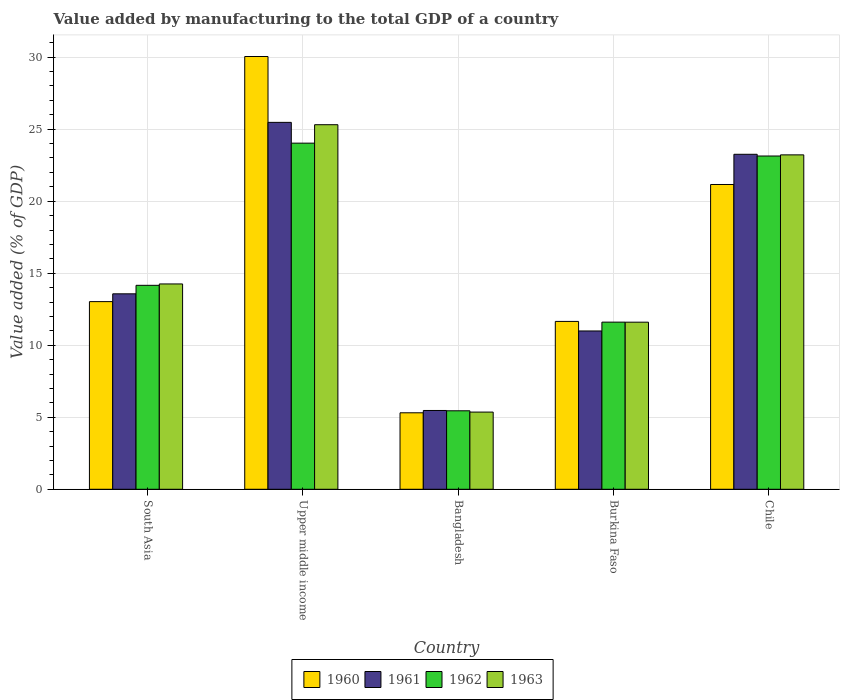How many groups of bars are there?
Offer a terse response. 5. Are the number of bars per tick equal to the number of legend labels?
Offer a very short reply. Yes. How many bars are there on the 3rd tick from the left?
Ensure brevity in your answer.  4. How many bars are there on the 5th tick from the right?
Provide a short and direct response. 4. In how many cases, is the number of bars for a given country not equal to the number of legend labels?
Keep it short and to the point. 0. What is the value added by manufacturing to the total GDP in 1961 in Upper middle income?
Offer a very short reply. 25.47. Across all countries, what is the maximum value added by manufacturing to the total GDP in 1961?
Offer a very short reply. 25.47. Across all countries, what is the minimum value added by manufacturing to the total GDP in 1963?
Your response must be concise. 5.36. In which country was the value added by manufacturing to the total GDP in 1961 maximum?
Your answer should be compact. Upper middle income. What is the total value added by manufacturing to the total GDP in 1961 in the graph?
Your response must be concise. 78.76. What is the difference between the value added by manufacturing to the total GDP in 1962 in Chile and that in South Asia?
Your answer should be very brief. 8.98. What is the difference between the value added by manufacturing to the total GDP in 1960 in South Asia and the value added by manufacturing to the total GDP in 1961 in Bangladesh?
Ensure brevity in your answer.  7.56. What is the average value added by manufacturing to the total GDP in 1960 per country?
Make the answer very short. 16.24. What is the difference between the value added by manufacturing to the total GDP of/in 1963 and value added by manufacturing to the total GDP of/in 1961 in Chile?
Your answer should be compact. -0.04. What is the ratio of the value added by manufacturing to the total GDP in 1960 in Burkina Faso to that in South Asia?
Offer a terse response. 0.89. Is the value added by manufacturing to the total GDP in 1961 in Burkina Faso less than that in South Asia?
Make the answer very short. Yes. What is the difference between the highest and the second highest value added by manufacturing to the total GDP in 1961?
Keep it short and to the point. 11.9. What is the difference between the highest and the lowest value added by manufacturing to the total GDP in 1960?
Ensure brevity in your answer.  24.74. In how many countries, is the value added by manufacturing to the total GDP in 1963 greater than the average value added by manufacturing to the total GDP in 1963 taken over all countries?
Your response must be concise. 2. Is the sum of the value added by manufacturing to the total GDP in 1963 in Chile and Upper middle income greater than the maximum value added by manufacturing to the total GDP in 1962 across all countries?
Your answer should be compact. Yes. What does the 3rd bar from the right in Bangladesh represents?
Ensure brevity in your answer.  1961. Are all the bars in the graph horizontal?
Keep it short and to the point. No. How many countries are there in the graph?
Keep it short and to the point. 5. What is the title of the graph?
Your answer should be very brief. Value added by manufacturing to the total GDP of a country. What is the label or title of the X-axis?
Your answer should be very brief. Country. What is the label or title of the Y-axis?
Your answer should be very brief. Value added (% of GDP). What is the Value added (% of GDP) in 1960 in South Asia?
Give a very brief answer. 13.03. What is the Value added (% of GDP) of 1961 in South Asia?
Your answer should be compact. 13.57. What is the Value added (% of GDP) in 1962 in South Asia?
Make the answer very short. 14.16. What is the Value added (% of GDP) of 1963 in South Asia?
Provide a short and direct response. 14.26. What is the Value added (% of GDP) in 1960 in Upper middle income?
Ensure brevity in your answer.  30.05. What is the Value added (% of GDP) in 1961 in Upper middle income?
Offer a very short reply. 25.47. What is the Value added (% of GDP) in 1962 in Upper middle income?
Provide a short and direct response. 24.03. What is the Value added (% of GDP) in 1963 in Upper middle income?
Provide a short and direct response. 25.31. What is the Value added (% of GDP) of 1960 in Bangladesh?
Make the answer very short. 5.31. What is the Value added (% of GDP) in 1961 in Bangladesh?
Ensure brevity in your answer.  5.47. What is the Value added (% of GDP) of 1962 in Bangladesh?
Provide a short and direct response. 5.45. What is the Value added (% of GDP) in 1963 in Bangladesh?
Provide a succinct answer. 5.36. What is the Value added (% of GDP) in 1960 in Burkina Faso?
Provide a succinct answer. 11.65. What is the Value added (% of GDP) of 1961 in Burkina Faso?
Give a very brief answer. 10.99. What is the Value added (% of GDP) of 1962 in Burkina Faso?
Keep it short and to the point. 11.6. What is the Value added (% of GDP) of 1963 in Burkina Faso?
Make the answer very short. 11.6. What is the Value added (% of GDP) in 1960 in Chile?
Ensure brevity in your answer.  21.16. What is the Value added (% of GDP) in 1961 in Chile?
Keep it short and to the point. 23.26. What is the Value added (% of GDP) of 1962 in Chile?
Your answer should be compact. 23.14. What is the Value added (% of GDP) of 1963 in Chile?
Offer a very short reply. 23.22. Across all countries, what is the maximum Value added (% of GDP) in 1960?
Your answer should be very brief. 30.05. Across all countries, what is the maximum Value added (% of GDP) of 1961?
Ensure brevity in your answer.  25.47. Across all countries, what is the maximum Value added (% of GDP) in 1962?
Your answer should be very brief. 24.03. Across all countries, what is the maximum Value added (% of GDP) of 1963?
Give a very brief answer. 25.31. Across all countries, what is the minimum Value added (% of GDP) of 1960?
Keep it short and to the point. 5.31. Across all countries, what is the minimum Value added (% of GDP) in 1961?
Make the answer very short. 5.47. Across all countries, what is the minimum Value added (% of GDP) in 1962?
Your answer should be compact. 5.45. Across all countries, what is the minimum Value added (% of GDP) of 1963?
Offer a terse response. 5.36. What is the total Value added (% of GDP) in 1960 in the graph?
Ensure brevity in your answer.  81.2. What is the total Value added (% of GDP) in 1961 in the graph?
Make the answer very short. 78.76. What is the total Value added (% of GDP) in 1962 in the graph?
Keep it short and to the point. 78.38. What is the total Value added (% of GDP) of 1963 in the graph?
Provide a short and direct response. 79.74. What is the difference between the Value added (% of GDP) in 1960 in South Asia and that in Upper middle income?
Your response must be concise. -17.02. What is the difference between the Value added (% of GDP) in 1961 in South Asia and that in Upper middle income?
Provide a short and direct response. -11.9. What is the difference between the Value added (% of GDP) in 1962 in South Asia and that in Upper middle income?
Your answer should be compact. -9.87. What is the difference between the Value added (% of GDP) of 1963 in South Asia and that in Upper middle income?
Your response must be concise. -11.05. What is the difference between the Value added (% of GDP) of 1960 in South Asia and that in Bangladesh?
Keep it short and to the point. 7.72. What is the difference between the Value added (% of GDP) in 1961 in South Asia and that in Bangladesh?
Provide a short and direct response. 8.1. What is the difference between the Value added (% of GDP) in 1962 in South Asia and that in Bangladesh?
Offer a very short reply. 8.71. What is the difference between the Value added (% of GDP) in 1963 in South Asia and that in Bangladesh?
Provide a succinct answer. 8.9. What is the difference between the Value added (% of GDP) in 1960 in South Asia and that in Burkina Faso?
Keep it short and to the point. 1.37. What is the difference between the Value added (% of GDP) of 1961 in South Asia and that in Burkina Faso?
Offer a very short reply. 2.58. What is the difference between the Value added (% of GDP) of 1962 in South Asia and that in Burkina Faso?
Your response must be concise. 2.56. What is the difference between the Value added (% of GDP) of 1963 in South Asia and that in Burkina Faso?
Give a very brief answer. 2.66. What is the difference between the Value added (% of GDP) of 1960 in South Asia and that in Chile?
Provide a short and direct response. -8.13. What is the difference between the Value added (% of GDP) in 1961 in South Asia and that in Chile?
Offer a terse response. -9.69. What is the difference between the Value added (% of GDP) of 1962 in South Asia and that in Chile?
Give a very brief answer. -8.98. What is the difference between the Value added (% of GDP) in 1963 in South Asia and that in Chile?
Give a very brief answer. -8.96. What is the difference between the Value added (% of GDP) of 1960 in Upper middle income and that in Bangladesh?
Ensure brevity in your answer.  24.74. What is the difference between the Value added (% of GDP) in 1961 in Upper middle income and that in Bangladesh?
Provide a short and direct response. 20. What is the difference between the Value added (% of GDP) in 1962 in Upper middle income and that in Bangladesh?
Provide a succinct answer. 18.58. What is the difference between the Value added (% of GDP) in 1963 in Upper middle income and that in Bangladesh?
Make the answer very short. 19.95. What is the difference between the Value added (% of GDP) in 1960 in Upper middle income and that in Burkina Faso?
Provide a short and direct response. 18.39. What is the difference between the Value added (% of GDP) of 1961 in Upper middle income and that in Burkina Faso?
Keep it short and to the point. 14.48. What is the difference between the Value added (% of GDP) of 1962 in Upper middle income and that in Burkina Faso?
Provide a short and direct response. 12.43. What is the difference between the Value added (% of GDP) in 1963 in Upper middle income and that in Burkina Faso?
Offer a terse response. 13.71. What is the difference between the Value added (% of GDP) of 1960 in Upper middle income and that in Chile?
Your answer should be very brief. 8.89. What is the difference between the Value added (% of GDP) of 1961 in Upper middle income and that in Chile?
Offer a terse response. 2.22. What is the difference between the Value added (% of GDP) in 1962 in Upper middle income and that in Chile?
Make the answer very short. 0.89. What is the difference between the Value added (% of GDP) of 1963 in Upper middle income and that in Chile?
Your answer should be compact. 2.09. What is the difference between the Value added (% of GDP) of 1960 in Bangladesh and that in Burkina Faso?
Your response must be concise. -6.34. What is the difference between the Value added (% of GDP) in 1961 in Bangladesh and that in Burkina Faso?
Your answer should be very brief. -5.52. What is the difference between the Value added (% of GDP) in 1962 in Bangladesh and that in Burkina Faso?
Your answer should be compact. -6.16. What is the difference between the Value added (% of GDP) of 1963 in Bangladesh and that in Burkina Faso?
Your response must be concise. -6.24. What is the difference between the Value added (% of GDP) in 1960 in Bangladesh and that in Chile?
Make the answer very short. -15.85. What is the difference between the Value added (% of GDP) in 1961 in Bangladesh and that in Chile?
Your answer should be very brief. -17.79. What is the difference between the Value added (% of GDP) in 1962 in Bangladesh and that in Chile?
Offer a very short reply. -17.69. What is the difference between the Value added (% of GDP) of 1963 in Bangladesh and that in Chile?
Give a very brief answer. -17.86. What is the difference between the Value added (% of GDP) in 1960 in Burkina Faso and that in Chile?
Your answer should be very brief. -9.51. What is the difference between the Value added (% of GDP) in 1961 in Burkina Faso and that in Chile?
Make the answer very short. -12.27. What is the difference between the Value added (% of GDP) of 1962 in Burkina Faso and that in Chile?
Make the answer very short. -11.53. What is the difference between the Value added (% of GDP) of 1963 in Burkina Faso and that in Chile?
Provide a succinct answer. -11.62. What is the difference between the Value added (% of GDP) of 1960 in South Asia and the Value added (% of GDP) of 1961 in Upper middle income?
Ensure brevity in your answer.  -12.44. What is the difference between the Value added (% of GDP) of 1960 in South Asia and the Value added (% of GDP) of 1962 in Upper middle income?
Provide a succinct answer. -11. What is the difference between the Value added (% of GDP) in 1960 in South Asia and the Value added (% of GDP) in 1963 in Upper middle income?
Make the answer very short. -12.28. What is the difference between the Value added (% of GDP) of 1961 in South Asia and the Value added (% of GDP) of 1962 in Upper middle income?
Keep it short and to the point. -10.46. What is the difference between the Value added (% of GDP) of 1961 in South Asia and the Value added (% of GDP) of 1963 in Upper middle income?
Provide a short and direct response. -11.74. What is the difference between the Value added (% of GDP) in 1962 in South Asia and the Value added (% of GDP) in 1963 in Upper middle income?
Ensure brevity in your answer.  -11.15. What is the difference between the Value added (% of GDP) in 1960 in South Asia and the Value added (% of GDP) in 1961 in Bangladesh?
Keep it short and to the point. 7.56. What is the difference between the Value added (% of GDP) of 1960 in South Asia and the Value added (% of GDP) of 1962 in Bangladesh?
Your answer should be compact. 7.58. What is the difference between the Value added (% of GDP) in 1960 in South Asia and the Value added (% of GDP) in 1963 in Bangladesh?
Ensure brevity in your answer.  7.67. What is the difference between the Value added (% of GDP) in 1961 in South Asia and the Value added (% of GDP) in 1962 in Bangladesh?
Your answer should be very brief. 8.12. What is the difference between the Value added (% of GDP) in 1961 in South Asia and the Value added (% of GDP) in 1963 in Bangladesh?
Your response must be concise. 8.21. What is the difference between the Value added (% of GDP) of 1962 in South Asia and the Value added (% of GDP) of 1963 in Bangladesh?
Provide a short and direct response. 8.8. What is the difference between the Value added (% of GDP) of 1960 in South Asia and the Value added (% of GDP) of 1961 in Burkina Faso?
Give a very brief answer. 2.04. What is the difference between the Value added (% of GDP) in 1960 in South Asia and the Value added (% of GDP) in 1962 in Burkina Faso?
Provide a succinct answer. 1.43. What is the difference between the Value added (% of GDP) of 1960 in South Asia and the Value added (% of GDP) of 1963 in Burkina Faso?
Provide a short and direct response. 1.43. What is the difference between the Value added (% of GDP) of 1961 in South Asia and the Value added (% of GDP) of 1962 in Burkina Faso?
Your response must be concise. 1.97. What is the difference between the Value added (% of GDP) in 1961 in South Asia and the Value added (% of GDP) in 1963 in Burkina Faso?
Ensure brevity in your answer.  1.97. What is the difference between the Value added (% of GDP) of 1962 in South Asia and the Value added (% of GDP) of 1963 in Burkina Faso?
Keep it short and to the point. 2.56. What is the difference between the Value added (% of GDP) of 1960 in South Asia and the Value added (% of GDP) of 1961 in Chile?
Provide a short and direct response. -10.23. What is the difference between the Value added (% of GDP) of 1960 in South Asia and the Value added (% of GDP) of 1962 in Chile?
Offer a terse response. -10.11. What is the difference between the Value added (% of GDP) in 1960 in South Asia and the Value added (% of GDP) in 1963 in Chile?
Keep it short and to the point. -10.19. What is the difference between the Value added (% of GDP) in 1961 in South Asia and the Value added (% of GDP) in 1962 in Chile?
Make the answer very short. -9.57. What is the difference between the Value added (% of GDP) of 1961 in South Asia and the Value added (% of GDP) of 1963 in Chile?
Offer a very short reply. -9.65. What is the difference between the Value added (% of GDP) in 1962 in South Asia and the Value added (% of GDP) in 1963 in Chile?
Make the answer very short. -9.06. What is the difference between the Value added (% of GDP) of 1960 in Upper middle income and the Value added (% of GDP) of 1961 in Bangladesh?
Provide a succinct answer. 24.57. What is the difference between the Value added (% of GDP) in 1960 in Upper middle income and the Value added (% of GDP) in 1962 in Bangladesh?
Give a very brief answer. 24.6. What is the difference between the Value added (% of GDP) in 1960 in Upper middle income and the Value added (% of GDP) in 1963 in Bangladesh?
Provide a succinct answer. 24.69. What is the difference between the Value added (% of GDP) of 1961 in Upper middle income and the Value added (% of GDP) of 1962 in Bangladesh?
Provide a short and direct response. 20.03. What is the difference between the Value added (% of GDP) of 1961 in Upper middle income and the Value added (% of GDP) of 1963 in Bangladesh?
Keep it short and to the point. 20.11. What is the difference between the Value added (% of GDP) of 1962 in Upper middle income and the Value added (% of GDP) of 1963 in Bangladesh?
Offer a terse response. 18.67. What is the difference between the Value added (% of GDP) of 1960 in Upper middle income and the Value added (% of GDP) of 1961 in Burkina Faso?
Provide a short and direct response. 19.05. What is the difference between the Value added (% of GDP) of 1960 in Upper middle income and the Value added (% of GDP) of 1962 in Burkina Faso?
Ensure brevity in your answer.  18.44. What is the difference between the Value added (% of GDP) of 1960 in Upper middle income and the Value added (% of GDP) of 1963 in Burkina Faso?
Make the answer very short. 18.44. What is the difference between the Value added (% of GDP) of 1961 in Upper middle income and the Value added (% of GDP) of 1962 in Burkina Faso?
Ensure brevity in your answer.  13.87. What is the difference between the Value added (% of GDP) of 1961 in Upper middle income and the Value added (% of GDP) of 1963 in Burkina Faso?
Offer a very short reply. 13.87. What is the difference between the Value added (% of GDP) in 1962 in Upper middle income and the Value added (% of GDP) in 1963 in Burkina Faso?
Provide a short and direct response. 12.43. What is the difference between the Value added (% of GDP) in 1960 in Upper middle income and the Value added (% of GDP) in 1961 in Chile?
Provide a short and direct response. 6.79. What is the difference between the Value added (% of GDP) in 1960 in Upper middle income and the Value added (% of GDP) in 1962 in Chile?
Your answer should be very brief. 6.91. What is the difference between the Value added (% of GDP) in 1960 in Upper middle income and the Value added (% of GDP) in 1963 in Chile?
Your response must be concise. 6.83. What is the difference between the Value added (% of GDP) of 1961 in Upper middle income and the Value added (% of GDP) of 1962 in Chile?
Your answer should be compact. 2.34. What is the difference between the Value added (% of GDP) of 1961 in Upper middle income and the Value added (% of GDP) of 1963 in Chile?
Offer a very short reply. 2.26. What is the difference between the Value added (% of GDP) in 1962 in Upper middle income and the Value added (% of GDP) in 1963 in Chile?
Provide a succinct answer. 0.81. What is the difference between the Value added (% of GDP) in 1960 in Bangladesh and the Value added (% of GDP) in 1961 in Burkina Faso?
Give a very brief answer. -5.68. What is the difference between the Value added (% of GDP) of 1960 in Bangladesh and the Value added (% of GDP) of 1962 in Burkina Faso?
Keep it short and to the point. -6.29. What is the difference between the Value added (% of GDP) of 1960 in Bangladesh and the Value added (% of GDP) of 1963 in Burkina Faso?
Offer a very short reply. -6.29. What is the difference between the Value added (% of GDP) of 1961 in Bangladesh and the Value added (% of GDP) of 1962 in Burkina Faso?
Provide a succinct answer. -6.13. What is the difference between the Value added (% of GDP) in 1961 in Bangladesh and the Value added (% of GDP) in 1963 in Burkina Faso?
Your answer should be very brief. -6.13. What is the difference between the Value added (% of GDP) of 1962 in Bangladesh and the Value added (% of GDP) of 1963 in Burkina Faso?
Your answer should be very brief. -6.15. What is the difference between the Value added (% of GDP) of 1960 in Bangladesh and the Value added (% of GDP) of 1961 in Chile?
Your response must be concise. -17.95. What is the difference between the Value added (% of GDP) in 1960 in Bangladesh and the Value added (% of GDP) in 1962 in Chile?
Keep it short and to the point. -17.83. What is the difference between the Value added (% of GDP) in 1960 in Bangladesh and the Value added (% of GDP) in 1963 in Chile?
Offer a terse response. -17.91. What is the difference between the Value added (% of GDP) in 1961 in Bangladesh and the Value added (% of GDP) in 1962 in Chile?
Offer a very short reply. -17.67. What is the difference between the Value added (% of GDP) in 1961 in Bangladesh and the Value added (% of GDP) in 1963 in Chile?
Give a very brief answer. -17.75. What is the difference between the Value added (% of GDP) in 1962 in Bangladesh and the Value added (% of GDP) in 1963 in Chile?
Your answer should be compact. -17.77. What is the difference between the Value added (% of GDP) in 1960 in Burkina Faso and the Value added (% of GDP) in 1961 in Chile?
Give a very brief answer. -11.6. What is the difference between the Value added (% of GDP) in 1960 in Burkina Faso and the Value added (% of GDP) in 1962 in Chile?
Your response must be concise. -11.48. What is the difference between the Value added (% of GDP) in 1960 in Burkina Faso and the Value added (% of GDP) in 1963 in Chile?
Your answer should be compact. -11.56. What is the difference between the Value added (% of GDP) in 1961 in Burkina Faso and the Value added (% of GDP) in 1962 in Chile?
Provide a short and direct response. -12.15. What is the difference between the Value added (% of GDP) of 1961 in Burkina Faso and the Value added (% of GDP) of 1963 in Chile?
Offer a terse response. -12.23. What is the difference between the Value added (% of GDP) in 1962 in Burkina Faso and the Value added (% of GDP) in 1963 in Chile?
Your response must be concise. -11.61. What is the average Value added (% of GDP) of 1960 per country?
Provide a succinct answer. 16.24. What is the average Value added (% of GDP) in 1961 per country?
Offer a terse response. 15.75. What is the average Value added (% of GDP) of 1962 per country?
Your response must be concise. 15.68. What is the average Value added (% of GDP) of 1963 per country?
Your answer should be compact. 15.95. What is the difference between the Value added (% of GDP) of 1960 and Value added (% of GDP) of 1961 in South Asia?
Provide a succinct answer. -0.54. What is the difference between the Value added (% of GDP) of 1960 and Value added (% of GDP) of 1962 in South Asia?
Ensure brevity in your answer.  -1.13. What is the difference between the Value added (% of GDP) in 1960 and Value added (% of GDP) in 1963 in South Asia?
Ensure brevity in your answer.  -1.23. What is the difference between the Value added (% of GDP) in 1961 and Value added (% of GDP) in 1962 in South Asia?
Offer a very short reply. -0.59. What is the difference between the Value added (% of GDP) in 1961 and Value added (% of GDP) in 1963 in South Asia?
Offer a very short reply. -0.69. What is the difference between the Value added (% of GDP) in 1962 and Value added (% of GDP) in 1963 in South Asia?
Offer a terse response. -0.1. What is the difference between the Value added (% of GDP) of 1960 and Value added (% of GDP) of 1961 in Upper middle income?
Give a very brief answer. 4.57. What is the difference between the Value added (% of GDP) in 1960 and Value added (% of GDP) in 1962 in Upper middle income?
Your response must be concise. 6.01. What is the difference between the Value added (% of GDP) in 1960 and Value added (% of GDP) in 1963 in Upper middle income?
Offer a terse response. 4.73. What is the difference between the Value added (% of GDP) in 1961 and Value added (% of GDP) in 1962 in Upper middle income?
Offer a terse response. 1.44. What is the difference between the Value added (% of GDP) of 1961 and Value added (% of GDP) of 1963 in Upper middle income?
Your answer should be very brief. 0.16. What is the difference between the Value added (% of GDP) in 1962 and Value added (% of GDP) in 1963 in Upper middle income?
Give a very brief answer. -1.28. What is the difference between the Value added (% of GDP) in 1960 and Value added (% of GDP) in 1961 in Bangladesh?
Offer a very short reply. -0.16. What is the difference between the Value added (% of GDP) in 1960 and Value added (% of GDP) in 1962 in Bangladesh?
Your answer should be compact. -0.14. What is the difference between the Value added (% of GDP) of 1960 and Value added (% of GDP) of 1963 in Bangladesh?
Offer a very short reply. -0.05. What is the difference between the Value added (% of GDP) in 1961 and Value added (% of GDP) in 1962 in Bangladesh?
Your answer should be very brief. 0.02. What is the difference between the Value added (% of GDP) in 1961 and Value added (% of GDP) in 1963 in Bangladesh?
Ensure brevity in your answer.  0.11. What is the difference between the Value added (% of GDP) of 1962 and Value added (% of GDP) of 1963 in Bangladesh?
Give a very brief answer. 0.09. What is the difference between the Value added (% of GDP) in 1960 and Value added (% of GDP) in 1961 in Burkina Faso?
Give a very brief answer. 0.66. What is the difference between the Value added (% of GDP) in 1960 and Value added (% of GDP) in 1962 in Burkina Faso?
Your answer should be compact. 0.05. What is the difference between the Value added (% of GDP) of 1960 and Value added (% of GDP) of 1963 in Burkina Faso?
Your answer should be compact. 0.05. What is the difference between the Value added (% of GDP) in 1961 and Value added (% of GDP) in 1962 in Burkina Faso?
Your response must be concise. -0.61. What is the difference between the Value added (% of GDP) of 1961 and Value added (% of GDP) of 1963 in Burkina Faso?
Make the answer very short. -0.61. What is the difference between the Value added (% of GDP) of 1962 and Value added (% of GDP) of 1963 in Burkina Faso?
Make the answer very short. 0. What is the difference between the Value added (% of GDP) in 1960 and Value added (% of GDP) in 1961 in Chile?
Offer a very short reply. -2.1. What is the difference between the Value added (% of GDP) of 1960 and Value added (% of GDP) of 1962 in Chile?
Your answer should be compact. -1.98. What is the difference between the Value added (% of GDP) in 1960 and Value added (% of GDP) in 1963 in Chile?
Your answer should be very brief. -2.06. What is the difference between the Value added (% of GDP) in 1961 and Value added (% of GDP) in 1962 in Chile?
Your response must be concise. 0.12. What is the difference between the Value added (% of GDP) in 1961 and Value added (% of GDP) in 1963 in Chile?
Your response must be concise. 0.04. What is the difference between the Value added (% of GDP) in 1962 and Value added (% of GDP) in 1963 in Chile?
Offer a very short reply. -0.08. What is the ratio of the Value added (% of GDP) of 1960 in South Asia to that in Upper middle income?
Your answer should be very brief. 0.43. What is the ratio of the Value added (% of GDP) of 1961 in South Asia to that in Upper middle income?
Keep it short and to the point. 0.53. What is the ratio of the Value added (% of GDP) of 1962 in South Asia to that in Upper middle income?
Provide a short and direct response. 0.59. What is the ratio of the Value added (% of GDP) of 1963 in South Asia to that in Upper middle income?
Make the answer very short. 0.56. What is the ratio of the Value added (% of GDP) in 1960 in South Asia to that in Bangladesh?
Your answer should be very brief. 2.45. What is the ratio of the Value added (% of GDP) of 1961 in South Asia to that in Bangladesh?
Your response must be concise. 2.48. What is the ratio of the Value added (% of GDP) in 1962 in South Asia to that in Bangladesh?
Your response must be concise. 2.6. What is the ratio of the Value added (% of GDP) of 1963 in South Asia to that in Bangladesh?
Your answer should be very brief. 2.66. What is the ratio of the Value added (% of GDP) of 1960 in South Asia to that in Burkina Faso?
Offer a very short reply. 1.12. What is the ratio of the Value added (% of GDP) of 1961 in South Asia to that in Burkina Faso?
Offer a very short reply. 1.23. What is the ratio of the Value added (% of GDP) of 1962 in South Asia to that in Burkina Faso?
Make the answer very short. 1.22. What is the ratio of the Value added (% of GDP) of 1963 in South Asia to that in Burkina Faso?
Provide a succinct answer. 1.23. What is the ratio of the Value added (% of GDP) of 1960 in South Asia to that in Chile?
Your answer should be very brief. 0.62. What is the ratio of the Value added (% of GDP) in 1961 in South Asia to that in Chile?
Keep it short and to the point. 0.58. What is the ratio of the Value added (% of GDP) of 1962 in South Asia to that in Chile?
Make the answer very short. 0.61. What is the ratio of the Value added (% of GDP) in 1963 in South Asia to that in Chile?
Your answer should be very brief. 0.61. What is the ratio of the Value added (% of GDP) of 1960 in Upper middle income to that in Bangladesh?
Offer a very short reply. 5.66. What is the ratio of the Value added (% of GDP) of 1961 in Upper middle income to that in Bangladesh?
Offer a terse response. 4.66. What is the ratio of the Value added (% of GDP) in 1962 in Upper middle income to that in Bangladesh?
Offer a very short reply. 4.41. What is the ratio of the Value added (% of GDP) of 1963 in Upper middle income to that in Bangladesh?
Provide a succinct answer. 4.72. What is the ratio of the Value added (% of GDP) in 1960 in Upper middle income to that in Burkina Faso?
Offer a terse response. 2.58. What is the ratio of the Value added (% of GDP) in 1961 in Upper middle income to that in Burkina Faso?
Give a very brief answer. 2.32. What is the ratio of the Value added (% of GDP) of 1962 in Upper middle income to that in Burkina Faso?
Provide a short and direct response. 2.07. What is the ratio of the Value added (% of GDP) of 1963 in Upper middle income to that in Burkina Faso?
Keep it short and to the point. 2.18. What is the ratio of the Value added (% of GDP) of 1960 in Upper middle income to that in Chile?
Make the answer very short. 1.42. What is the ratio of the Value added (% of GDP) of 1961 in Upper middle income to that in Chile?
Keep it short and to the point. 1.1. What is the ratio of the Value added (% of GDP) in 1962 in Upper middle income to that in Chile?
Your answer should be very brief. 1.04. What is the ratio of the Value added (% of GDP) of 1963 in Upper middle income to that in Chile?
Your answer should be very brief. 1.09. What is the ratio of the Value added (% of GDP) of 1960 in Bangladesh to that in Burkina Faso?
Offer a terse response. 0.46. What is the ratio of the Value added (% of GDP) of 1961 in Bangladesh to that in Burkina Faso?
Offer a terse response. 0.5. What is the ratio of the Value added (% of GDP) of 1962 in Bangladesh to that in Burkina Faso?
Offer a terse response. 0.47. What is the ratio of the Value added (% of GDP) in 1963 in Bangladesh to that in Burkina Faso?
Your answer should be compact. 0.46. What is the ratio of the Value added (% of GDP) of 1960 in Bangladesh to that in Chile?
Offer a very short reply. 0.25. What is the ratio of the Value added (% of GDP) of 1961 in Bangladesh to that in Chile?
Your answer should be compact. 0.24. What is the ratio of the Value added (% of GDP) in 1962 in Bangladesh to that in Chile?
Give a very brief answer. 0.24. What is the ratio of the Value added (% of GDP) in 1963 in Bangladesh to that in Chile?
Your response must be concise. 0.23. What is the ratio of the Value added (% of GDP) of 1960 in Burkina Faso to that in Chile?
Offer a very short reply. 0.55. What is the ratio of the Value added (% of GDP) in 1961 in Burkina Faso to that in Chile?
Ensure brevity in your answer.  0.47. What is the ratio of the Value added (% of GDP) in 1962 in Burkina Faso to that in Chile?
Provide a short and direct response. 0.5. What is the ratio of the Value added (% of GDP) in 1963 in Burkina Faso to that in Chile?
Give a very brief answer. 0.5. What is the difference between the highest and the second highest Value added (% of GDP) of 1960?
Keep it short and to the point. 8.89. What is the difference between the highest and the second highest Value added (% of GDP) in 1961?
Your answer should be very brief. 2.22. What is the difference between the highest and the second highest Value added (% of GDP) of 1962?
Provide a short and direct response. 0.89. What is the difference between the highest and the second highest Value added (% of GDP) of 1963?
Ensure brevity in your answer.  2.09. What is the difference between the highest and the lowest Value added (% of GDP) in 1960?
Provide a succinct answer. 24.74. What is the difference between the highest and the lowest Value added (% of GDP) in 1961?
Give a very brief answer. 20. What is the difference between the highest and the lowest Value added (% of GDP) of 1962?
Give a very brief answer. 18.58. What is the difference between the highest and the lowest Value added (% of GDP) of 1963?
Your response must be concise. 19.95. 